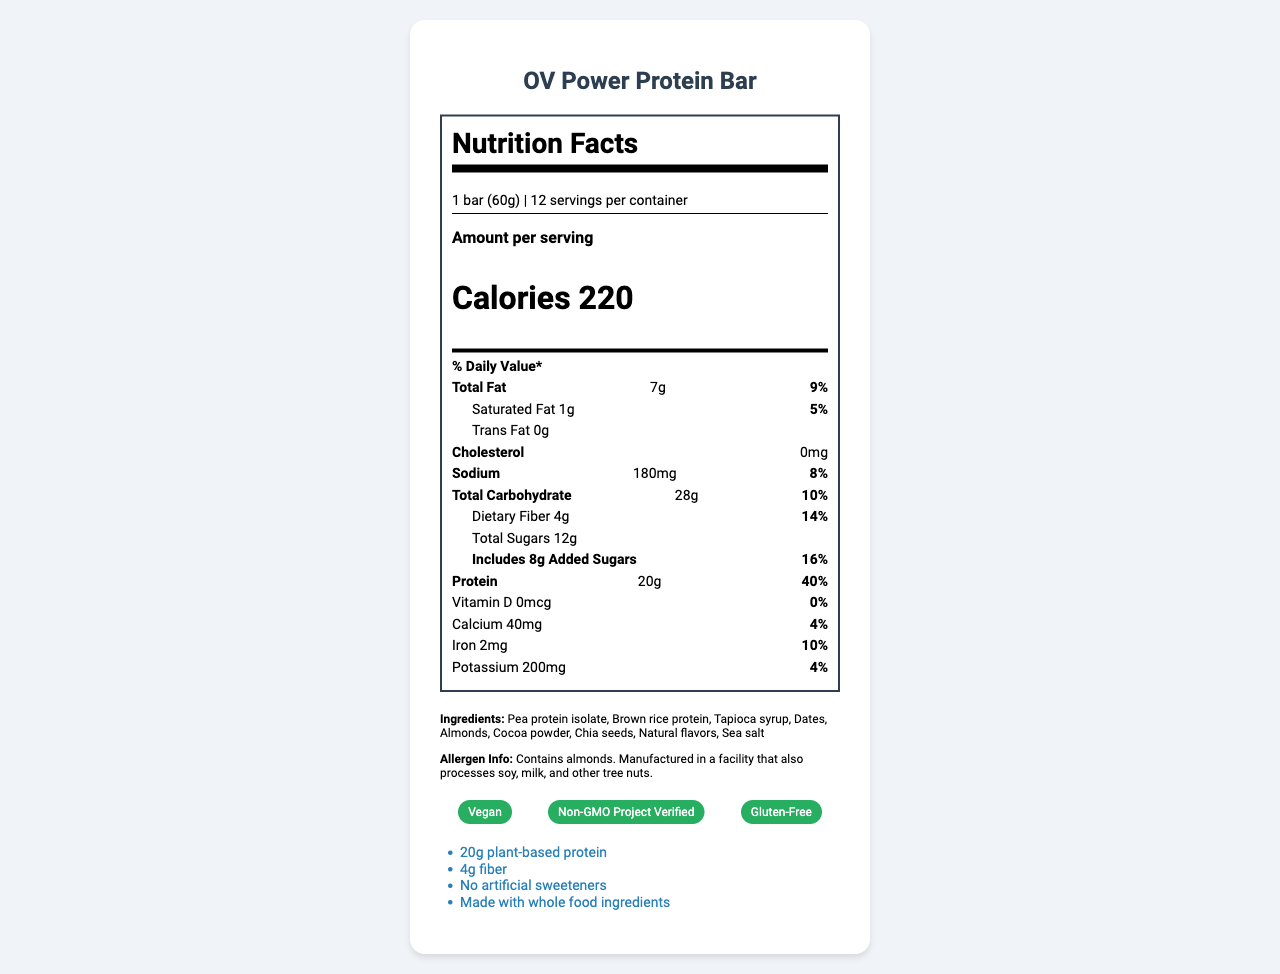what is the serving size of the OV Power Protein Bar? The serving size is clearly stated in the nutrition label as "1 bar (60g)".
Answer: 1 bar (60g) how many servings are there per container? The document specifies that there are 12 servings per container.
Answer: 12 how many total grams of protein are there in one serving? The amount of protein in one serving is explicitly listed as 20g.
Answer: 20g what percentage of the daily value does the dietary fiber content represent? The document shows that the dietary fiber content represents 14% of the daily value.
Answer: 14% how much added sugar is there in one serving? The amount of added sugars is directly mentioned in the nutrition facts as 8g.
Answer: 8g what is the total calorie content per serving? A. 180 B. 200 C. 220 D. 250 The label clearly states that the total calorie content per serving is 220 calories.
Answer: C. 220 what are the certifications of the OV Power Protein Bar? A. Vegan, Non-GMO Project Verified, Gluten-Free B. Organic, Vegan, Gluten-Free C. Non-GMO Project Verified, Organic, Dairy-Free The document lists the certifications as "Vegan," "Non-GMO Project Verified," and "Gluten-Free."
Answer: A. Vegan, Non-GMO Project Verified, Gluten-Free is the OV Power Protein Bar vegan? The document includes a "Vegan" certification.
Answer: Yes summarize the main points of the OV Power Protein Bar's nutrition facts and marketing claims. The document highlights key nutritional information including calorie, protein, and sugar content, lists certifications, and outlines the target market and marketing claims.
Answer: The OV Power Protein Bar contains 220 calories per serving, offers 20g of plant-based protein, 4g of fiber, and 12g of sugars including 8g of added sugars. It is vegan, Non-GMO Project Certified, and gluten-free. The product targets health-conscious athletes and fitness enthusiasts and is marketed for its whole food ingredients and no artificial sweeteners. what is the total carbohydrate content per serving? The total carbohydrate content is listed as 28g per serving.
Answer: 28g what is the main source of protein in the OV Power Protein Bar? The ingredients list shows that the main sources of protein are pea protein isolate and brown rice protein.
Answer: Pea protein isolate and Brown rice protein does the document state if the OV Power Protein Bar has any cholesterol? The nutrition facts label specifies that the cholesterol amount is 0mg.
Answer: No, the cholesterol amount is 0mg what are the growth potential strategies mentioned for the OV Power Protein Bar? The document mentions growth potential strategies such as expanding into new retail channels and e-commerce platforms.
Answer: Expanding into new retail channels and e-commerce platforms does the OV Power Protein Bar contain any artificial sweeteners? The marketing claims specify that the product contains no artificial sweeteners.
Answer: No who is the target market for the OV Power Protein Bar? The document states that the target market is health-conscious athletes and fitness enthusiasts.
Answer: Health-conscious athletes and fitness enthusiasts how much calcium is there in one serving of the OV Power Protein Bar? The label lists the calcium content as 40mg per serving.
Answer: 40mg what is the percentage daily value of iron provided by one serving? The nutrition label shows that the percentage daily value of iron is 10%.
Answer: 10% what is the daily value percentage of saturated fat in one serving? The label indicates that the saturated fat content represents 5% of the daily value.
Answer: 5% is the packaging of the OV Power Protein Bar eco-friendly? The investor insights section mentions that the packaging is made from 100% post-consumer recycled materials, indicating it is eco-friendly.
Answer: Yes how many grams of trans fat are in one serving? The document states that there are 0 grams of trans fat in one serving.
Answer: 0g how does the OV Power Protein Bar differentiate itself from other vegan snacks? The document states that the high protein content is a competitive advantage compared to other vegan snacks.
Answer: High protein content 